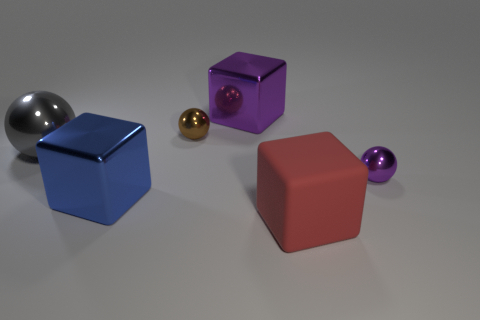Can you tell me what the smallest object in the image is? The smallest object in the image is the small gold sphere adjacent to the large gray sphere. And what does the arrangement of these objects suggest? The arrangement of objects might suggest a study in geometry and color contrast, with varying shapes and sizes showcasing how different objects interact visually within a shared space. 